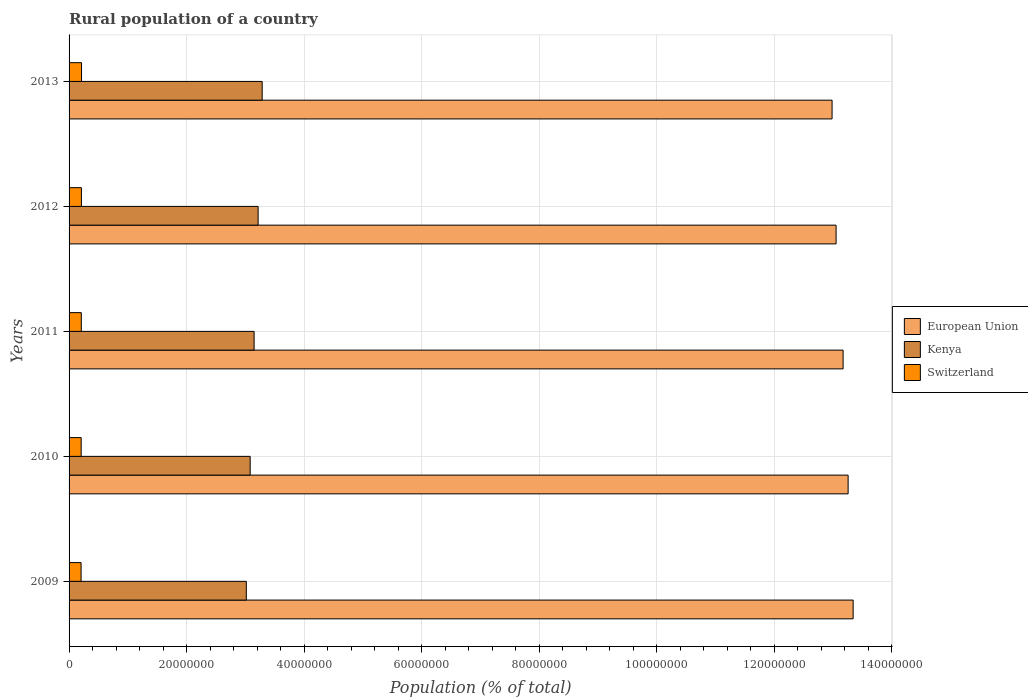How many groups of bars are there?
Ensure brevity in your answer.  5. Are the number of bars per tick equal to the number of legend labels?
Provide a short and direct response. Yes. How many bars are there on the 5th tick from the top?
Your answer should be compact. 3. In how many cases, is the number of bars for a given year not equal to the number of legend labels?
Give a very brief answer. 0. What is the rural population in Kenya in 2011?
Your answer should be very brief. 3.15e+07. Across all years, what is the maximum rural population in Kenya?
Provide a succinct answer. 3.29e+07. Across all years, what is the minimum rural population in Switzerland?
Offer a terse response. 2.04e+06. What is the total rural population in European Union in the graph?
Ensure brevity in your answer.  6.58e+08. What is the difference between the rural population in Kenya in 2010 and that in 2013?
Offer a terse response. -2.04e+06. What is the difference between the rural population in Kenya in 2010 and the rural population in Switzerland in 2009?
Make the answer very short. 2.88e+07. What is the average rural population in European Union per year?
Provide a short and direct response. 1.32e+08. In the year 2013, what is the difference between the rural population in European Union and rural population in Kenya?
Your answer should be compact. 9.70e+07. In how many years, is the rural population in Switzerland greater than 60000000 %?
Provide a succinct answer. 0. What is the ratio of the rural population in European Union in 2009 to that in 2012?
Keep it short and to the point. 1.02. What is the difference between the highest and the second highest rural population in Kenya?
Your response must be concise. 6.91e+05. What is the difference between the highest and the lowest rural population in European Union?
Offer a very short reply. 3.59e+06. Is the sum of the rural population in Kenya in 2010 and 2013 greater than the maximum rural population in Switzerland across all years?
Ensure brevity in your answer.  Yes. What does the 2nd bar from the bottom in 2013 represents?
Your response must be concise. Kenya. How many bars are there?
Your answer should be very brief. 15. What is the difference between two consecutive major ticks on the X-axis?
Provide a succinct answer. 2.00e+07. How are the legend labels stacked?
Your answer should be compact. Vertical. What is the title of the graph?
Ensure brevity in your answer.  Rural population of a country. Does "Caribbean small states" appear as one of the legend labels in the graph?
Your answer should be very brief. No. What is the label or title of the X-axis?
Provide a short and direct response. Population (% of total). What is the label or title of the Y-axis?
Keep it short and to the point. Years. What is the Population (% of total) in European Union in 2009?
Give a very brief answer. 1.33e+08. What is the Population (% of total) in Kenya in 2009?
Your answer should be compact. 3.02e+07. What is the Population (% of total) of Switzerland in 2009?
Keep it short and to the point. 2.04e+06. What is the Population (% of total) of European Union in 2010?
Offer a terse response. 1.33e+08. What is the Population (% of total) in Kenya in 2010?
Ensure brevity in your answer.  3.08e+07. What is the Population (% of total) in Switzerland in 2010?
Provide a succinct answer. 2.06e+06. What is the Population (% of total) of European Union in 2011?
Offer a terse response. 1.32e+08. What is the Population (% of total) in Kenya in 2011?
Give a very brief answer. 3.15e+07. What is the Population (% of total) in Switzerland in 2011?
Offer a very short reply. 2.08e+06. What is the Population (% of total) of European Union in 2012?
Ensure brevity in your answer.  1.31e+08. What is the Population (% of total) in Kenya in 2012?
Ensure brevity in your answer.  3.22e+07. What is the Population (% of total) of Switzerland in 2012?
Provide a succinct answer. 2.10e+06. What is the Population (% of total) in European Union in 2013?
Make the answer very short. 1.30e+08. What is the Population (% of total) of Kenya in 2013?
Your answer should be very brief. 3.29e+07. What is the Population (% of total) of Switzerland in 2013?
Offer a terse response. 2.12e+06. Across all years, what is the maximum Population (% of total) of European Union?
Provide a succinct answer. 1.33e+08. Across all years, what is the maximum Population (% of total) of Kenya?
Provide a short and direct response. 3.29e+07. Across all years, what is the maximum Population (% of total) of Switzerland?
Give a very brief answer. 2.12e+06. Across all years, what is the minimum Population (% of total) of European Union?
Make the answer very short. 1.30e+08. Across all years, what is the minimum Population (% of total) in Kenya?
Offer a very short reply. 3.02e+07. Across all years, what is the minimum Population (% of total) of Switzerland?
Make the answer very short. 2.04e+06. What is the total Population (% of total) in European Union in the graph?
Offer a terse response. 6.58e+08. What is the total Population (% of total) of Kenya in the graph?
Your answer should be very brief. 1.58e+08. What is the total Population (% of total) in Switzerland in the graph?
Provide a succinct answer. 1.04e+07. What is the difference between the Population (% of total) in European Union in 2009 and that in 2010?
Keep it short and to the point. 8.54e+05. What is the difference between the Population (% of total) of Kenya in 2009 and that in 2010?
Make the answer very short. -6.56e+05. What is the difference between the Population (% of total) in Switzerland in 2009 and that in 2010?
Give a very brief answer. -1.84e+04. What is the difference between the Population (% of total) in European Union in 2009 and that in 2011?
Offer a very short reply. 1.71e+06. What is the difference between the Population (% of total) in Kenya in 2009 and that in 2011?
Your answer should be compact. -1.33e+06. What is the difference between the Population (% of total) of Switzerland in 2009 and that in 2011?
Your answer should be very brief. -3.84e+04. What is the difference between the Population (% of total) of European Union in 2009 and that in 2012?
Give a very brief answer. 2.90e+06. What is the difference between the Population (% of total) in Kenya in 2009 and that in 2012?
Provide a short and direct response. -2.01e+06. What is the difference between the Population (% of total) of Switzerland in 2009 and that in 2012?
Make the answer very short. -5.76e+04. What is the difference between the Population (% of total) of European Union in 2009 and that in 2013?
Your answer should be very brief. 3.59e+06. What is the difference between the Population (% of total) of Kenya in 2009 and that in 2013?
Provide a succinct answer. -2.70e+06. What is the difference between the Population (% of total) of Switzerland in 2009 and that in 2013?
Keep it short and to the point. -7.80e+04. What is the difference between the Population (% of total) in European Union in 2010 and that in 2011?
Offer a terse response. 8.56e+05. What is the difference between the Population (% of total) in Kenya in 2010 and that in 2011?
Offer a terse response. -6.70e+05. What is the difference between the Population (% of total) of Switzerland in 2010 and that in 2011?
Offer a very short reply. -2.00e+04. What is the difference between the Population (% of total) in European Union in 2010 and that in 2012?
Your answer should be compact. 2.05e+06. What is the difference between the Population (% of total) of Kenya in 2010 and that in 2012?
Offer a very short reply. -1.35e+06. What is the difference between the Population (% of total) of Switzerland in 2010 and that in 2012?
Keep it short and to the point. -3.92e+04. What is the difference between the Population (% of total) of European Union in 2010 and that in 2013?
Ensure brevity in your answer.  2.73e+06. What is the difference between the Population (% of total) of Kenya in 2010 and that in 2013?
Make the answer very short. -2.04e+06. What is the difference between the Population (% of total) in Switzerland in 2010 and that in 2013?
Your answer should be very brief. -5.96e+04. What is the difference between the Population (% of total) of European Union in 2011 and that in 2012?
Offer a very short reply. 1.19e+06. What is the difference between the Population (% of total) in Kenya in 2011 and that in 2012?
Provide a short and direct response. -6.82e+05. What is the difference between the Population (% of total) in Switzerland in 2011 and that in 2012?
Give a very brief answer. -1.92e+04. What is the difference between the Population (% of total) of European Union in 2011 and that in 2013?
Your answer should be very brief. 1.88e+06. What is the difference between the Population (% of total) in Kenya in 2011 and that in 2013?
Offer a terse response. -1.37e+06. What is the difference between the Population (% of total) in Switzerland in 2011 and that in 2013?
Keep it short and to the point. -3.96e+04. What is the difference between the Population (% of total) in European Union in 2012 and that in 2013?
Offer a terse response. 6.83e+05. What is the difference between the Population (% of total) in Kenya in 2012 and that in 2013?
Offer a terse response. -6.91e+05. What is the difference between the Population (% of total) in Switzerland in 2012 and that in 2013?
Your response must be concise. -2.04e+04. What is the difference between the Population (% of total) in European Union in 2009 and the Population (% of total) in Kenya in 2010?
Ensure brevity in your answer.  1.03e+08. What is the difference between the Population (% of total) in European Union in 2009 and the Population (% of total) in Switzerland in 2010?
Your answer should be very brief. 1.31e+08. What is the difference between the Population (% of total) of Kenya in 2009 and the Population (% of total) of Switzerland in 2010?
Your response must be concise. 2.81e+07. What is the difference between the Population (% of total) of European Union in 2009 and the Population (% of total) of Kenya in 2011?
Offer a very short reply. 1.02e+08. What is the difference between the Population (% of total) of European Union in 2009 and the Population (% of total) of Switzerland in 2011?
Keep it short and to the point. 1.31e+08. What is the difference between the Population (% of total) of Kenya in 2009 and the Population (% of total) of Switzerland in 2011?
Your answer should be very brief. 2.81e+07. What is the difference between the Population (% of total) in European Union in 2009 and the Population (% of total) in Kenya in 2012?
Your response must be concise. 1.01e+08. What is the difference between the Population (% of total) in European Union in 2009 and the Population (% of total) in Switzerland in 2012?
Provide a succinct answer. 1.31e+08. What is the difference between the Population (% of total) in Kenya in 2009 and the Population (% of total) in Switzerland in 2012?
Your answer should be compact. 2.81e+07. What is the difference between the Population (% of total) in European Union in 2009 and the Population (% of total) in Kenya in 2013?
Keep it short and to the point. 1.01e+08. What is the difference between the Population (% of total) of European Union in 2009 and the Population (% of total) of Switzerland in 2013?
Your response must be concise. 1.31e+08. What is the difference between the Population (% of total) of Kenya in 2009 and the Population (% of total) of Switzerland in 2013?
Provide a succinct answer. 2.80e+07. What is the difference between the Population (% of total) of European Union in 2010 and the Population (% of total) of Kenya in 2011?
Your answer should be very brief. 1.01e+08. What is the difference between the Population (% of total) in European Union in 2010 and the Population (% of total) in Switzerland in 2011?
Offer a very short reply. 1.31e+08. What is the difference between the Population (% of total) of Kenya in 2010 and the Population (% of total) of Switzerland in 2011?
Give a very brief answer. 2.87e+07. What is the difference between the Population (% of total) in European Union in 2010 and the Population (% of total) in Kenya in 2012?
Ensure brevity in your answer.  1.00e+08. What is the difference between the Population (% of total) in European Union in 2010 and the Population (% of total) in Switzerland in 2012?
Give a very brief answer. 1.30e+08. What is the difference between the Population (% of total) in Kenya in 2010 and the Population (% of total) in Switzerland in 2012?
Keep it short and to the point. 2.87e+07. What is the difference between the Population (% of total) of European Union in 2010 and the Population (% of total) of Kenya in 2013?
Give a very brief answer. 9.97e+07. What is the difference between the Population (% of total) of European Union in 2010 and the Population (% of total) of Switzerland in 2013?
Ensure brevity in your answer.  1.30e+08. What is the difference between the Population (% of total) of Kenya in 2010 and the Population (% of total) of Switzerland in 2013?
Provide a succinct answer. 2.87e+07. What is the difference between the Population (% of total) in European Union in 2011 and the Population (% of total) in Kenya in 2012?
Ensure brevity in your answer.  9.96e+07. What is the difference between the Population (% of total) in European Union in 2011 and the Population (% of total) in Switzerland in 2012?
Provide a succinct answer. 1.30e+08. What is the difference between the Population (% of total) of Kenya in 2011 and the Population (% of total) of Switzerland in 2012?
Give a very brief answer. 2.94e+07. What is the difference between the Population (% of total) in European Union in 2011 and the Population (% of total) in Kenya in 2013?
Your answer should be compact. 9.89e+07. What is the difference between the Population (% of total) in European Union in 2011 and the Population (% of total) in Switzerland in 2013?
Your answer should be compact. 1.30e+08. What is the difference between the Population (% of total) of Kenya in 2011 and the Population (% of total) of Switzerland in 2013?
Your answer should be compact. 2.94e+07. What is the difference between the Population (% of total) in European Union in 2012 and the Population (% of total) in Kenya in 2013?
Offer a terse response. 9.77e+07. What is the difference between the Population (% of total) in European Union in 2012 and the Population (% of total) in Switzerland in 2013?
Give a very brief answer. 1.28e+08. What is the difference between the Population (% of total) of Kenya in 2012 and the Population (% of total) of Switzerland in 2013?
Your answer should be compact. 3.01e+07. What is the average Population (% of total) of European Union per year?
Make the answer very short. 1.32e+08. What is the average Population (% of total) of Kenya per year?
Keep it short and to the point. 3.15e+07. What is the average Population (% of total) of Switzerland per year?
Make the answer very short. 2.08e+06. In the year 2009, what is the difference between the Population (% of total) in European Union and Population (% of total) in Kenya?
Your answer should be compact. 1.03e+08. In the year 2009, what is the difference between the Population (% of total) of European Union and Population (% of total) of Switzerland?
Provide a succinct answer. 1.31e+08. In the year 2009, what is the difference between the Population (% of total) of Kenya and Population (% of total) of Switzerland?
Ensure brevity in your answer.  2.81e+07. In the year 2010, what is the difference between the Population (% of total) in European Union and Population (% of total) in Kenya?
Your response must be concise. 1.02e+08. In the year 2010, what is the difference between the Population (% of total) in European Union and Population (% of total) in Switzerland?
Provide a succinct answer. 1.31e+08. In the year 2010, what is the difference between the Population (% of total) in Kenya and Population (% of total) in Switzerland?
Ensure brevity in your answer.  2.88e+07. In the year 2011, what is the difference between the Population (% of total) in European Union and Population (% of total) in Kenya?
Offer a terse response. 1.00e+08. In the year 2011, what is the difference between the Population (% of total) of European Union and Population (% of total) of Switzerland?
Ensure brevity in your answer.  1.30e+08. In the year 2011, what is the difference between the Population (% of total) of Kenya and Population (% of total) of Switzerland?
Provide a short and direct response. 2.94e+07. In the year 2012, what is the difference between the Population (% of total) of European Union and Population (% of total) of Kenya?
Offer a very short reply. 9.84e+07. In the year 2012, what is the difference between the Population (% of total) of European Union and Population (% of total) of Switzerland?
Provide a succinct answer. 1.28e+08. In the year 2012, what is the difference between the Population (% of total) in Kenya and Population (% of total) in Switzerland?
Make the answer very short. 3.01e+07. In the year 2013, what is the difference between the Population (% of total) of European Union and Population (% of total) of Kenya?
Ensure brevity in your answer.  9.70e+07. In the year 2013, what is the difference between the Population (% of total) in European Union and Population (% of total) in Switzerland?
Offer a very short reply. 1.28e+08. In the year 2013, what is the difference between the Population (% of total) of Kenya and Population (% of total) of Switzerland?
Your answer should be very brief. 3.07e+07. What is the ratio of the Population (% of total) in European Union in 2009 to that in 2010?
Give a very brief answer. 1.01. What is the ratio of the Population (% of total) of Kenya in 2009 to that in 2010?
Provide a succinct answer. 0.98. What is the ratio of the Population (% of total) of Switzerland in 2009 to that in 2010?
Make the answer very short. 0.99. What is the ratio of the Population (% of total) of Kenya in 2009 to that in 2011?
Offer a very short reply. 0.96. What is the ratio of the Population (% of total) in Switzerland in 2009 to that in 2011?
Provide a short and direct response. 0.98. What is the ratio of the Population (% of total) of European Union in 2009 to that in 2012?
Keep it short and to the point. 1.02. What is the ratio of the Population (% of total) in Kenya in 2009 to that in 2012?
Your answer should be very brief. 0.94. What is the ratio of the Population (% of total) of Switzerland in 2009 to that in 2012?
Ensure brevity in your answer.  0.97. What is the ratio of the Population (% of total) in European Union in 2009 to that in 2013?
Your answer should be very brief. 1.03. What is the ratio of the Population (% of total) in Kenya in 2009 to that in 2013?
Your answer should be very brief. 0.92. What is the ratio of the Population (% of total) of Switzerland in 2009 to that in 2013?
Keep it short and to the point. 0.96. What is the ratio of the Population (% of total) of Kenya in 2010 to that in 2011?
Provide a short and direct response. 0.98. What is the ratio of the Population (% of total) in European Union in 2010 to that in 2012?
Offer a terse response. 1.02. What is the ratio of the Population (% of total) in Kenya in 2010 to that in 2012?
Keep it short and to the point. 0.96. What is the ratio of the Population (% of total) in Switzerland in 2010 to that in 2012?
Ensure brevity in your answer.  0.98. What is the ratio of the Population (% of total) in Kenya in 2010 to that in 2013?
Ensure brevity in your answer.  0.94. What is the ratio of the Population (% of total) of Switzerland in 2010 to that in 2013?
Your response must be concise. 0.97. What is the ratio of the Population (% of total) in European Union in 2011 to that in 2012?
Your answer should be very brief. 1.01. What is the ratio of the Population (% of total) in Kenya in 2011 to that in 2012?
Provide a succinct answer. 0.98. What is the ratio of the Population (% of total) in Switzerland in 2011 to that in 2012?
Your answer should be compact. 0.99. What is the ratio of the Population (% of total) of European Union in 2011 to that in 2013?
Ensure brevity in your answer.  1.01. What is the ratio of the Population (% of total) in Kenya in 2011 to that in 2013?
Offer a terse response. 0.96. What is the ratio of the Population (% of total) of Switzerland in 2011 to that in 2013?
Make the answer very short. 0.98. What is the ratio of the Population (% of total) of European Union in 2012 to that in 2013?
Ensure brevity in your answer.  1.01. What is the difference between the highest and the second highest Population (% of total) in European Union?
Provide a short and direct response. 8.54e+05. What is the difference between the highest and the second highest Population (% of total) in Kenya?
Make the answer very short. 6.91e+05. What is the difference between the highest and the second highest Population (% of total) in Switzerland?
Your answer should be very brief. 2.04e+04. What is the difference between the highest and the lowest Population (% of total) of European Union?
Offer a terse response. 3.59e+06. What is the difference between the highest and the lowest Population (% of total) in Kenya?
Your answer should be very brief. 2.70e+06. What is the difference between the highest and the lowest Population (% of total) of Switzerland?
Ensure brevity in your answer.  7.80e+04. 